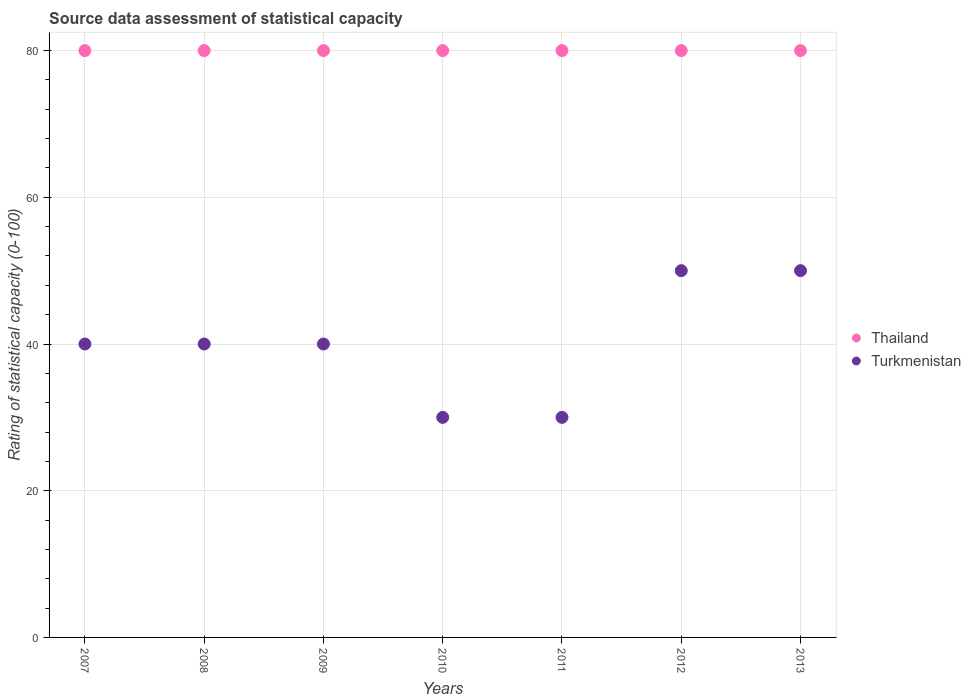How many different coloured dotlines are there?
Provide a short and direct response. 2. What is the rating of statistical capacity in Thailand in 2007?
Give a very brief answer. 80. Across all years, what is the maximum rating of statistical capacity in Turkmenistan?
Your answer should be compact. 50. Across all years, what is the minimum rating of statistical capacity in Thailand?
Your response must be concise. 80. What is the total rating of statistical capacity in Thailand in the graph?
Give a very brief answer. 560. What is the difference between the rating of statistical capacity in Thailand in 2007 and that in 2013?
Provide a short and direct response. 0. What is the difference between the rating of statistical capacity in Thailand in 2008 and the rating of statistical capacity in Turkmenistan in 2012?
Make the answer very short. 30. In the year 2011, what is the difference between the rating of statistical capacity in Turkmenistan and rating of statistical capacity in Thailand?
Your response must be concise. -50. What is the ratio of the rating of statistical capacity in Turkmenistan in 2010 to that in 2012?
Offer a terse response. 0.6. Is the rating of statistical capacity in Thailand in 2009 less than that in 2012?
Provide a succinct answer. No. Is the difference between the rating of statistical capacity in Turkmenistan in 2008 and 2012 greater than the difference between the rating of statistical capacity in Thailand in 2008 and 2012?
Your response must be concise. No. What is the difference between the highest and the lowest rating of statistical capacity in Turkmenistan?
Offer a terse response. 20. In how many years, is the rating of statistical capacity in Thailand greater than the average rating of statistical capacity in Thailand taken over all years?
Provide a short and direct response. 0. Does the rating of statistical capacity in Turkmenistan monotonically increase over the years?
Offer a terse response. No. Does the graph contain any zero values?
Provide a short and direct response. No. Does the graph contain grids?
Ensure brevity in your answer.  Yes. How many legend labels are there?
Your answer should be very brief. 2. How are the legend labels stacked?
Provide a short and direct response. Vertical. What is the title of the graph?
Offer a terse response. Source data assessment of statistical capacity. Does "Virgin Islands" appear as one of the legend labels in the graph?
Give a very brief answer. No. What is the label or title of the Y-axis?
Provide a succinct answer. Rating of statistical capacity (0-100). What is the Rating of statistical capacity (0-100) in Thailand in 2007?
Offer a terse response. 80. What is the Rating of statistical capacity (0-100) in Thailand in 2008?
Your response must be concise. 80. What is the Rating of statistical capacity (0-100) of Thailand in 2009?
Offer a very short reply. 80. What is the Rating of statistical capacity (0-100) in Thailand in 2011?
Your response must be concise. 80. What is the Rating of statistical capacity (0-100) of Turkmenistan in 2012?
Your response must be concise. 50. What is the Rating of statistical capacity (0-100) in Thailand in 2013?
Your response must be concise. 80. Across all years, what is the maximum Rating of statistical capacity (0-100) in Turkmenistan?
Your response must be concise. 50. Across all years, what is the minimum Rating of statistical capacity (0-100) in Thailand?
Provide a succinct answer. 80. Across all years, what is the minimum Rating of statistical capacity (0-100) in Turkmenistan?
Give a very brief answer. 30. What is the total Rating of statistical capacity (0-100) of Thailand in the graph?
Your answer should be very brief. 560. What is the total Rating of statistical capacity (0-100) in Turkmenistan in the graph?
Provide a short and direct response. 280. What is the difference between the Rating of statistical capacity (0-100) of Turkmenistan in 2007 and that in 2008?
Ensure brevity in your answer.  0. What is the difference between the Rating of statistical capacity (0-100) in Thailand in 2007 and that in 2009?
Keep it short and to the point. 0. What is the difference between the Rating of statistical capacity (0-100) of Thailand in 2007 and that in 2010?
Your answer should be very brief. 0. What is the difference between the Rating of statistical capacity (0-100) of Turkmenistan in 2007 and that in 2010?
Keep it short and to the point. 10. What is the difference between the Rating of statistical capacity (0-100) of Thailand in 2007 and that in 2011?
Keep it short and to the point. 0. What is the difference between the Rating of statistical capacity (0-100) in Turkmenistan in 2007 and that in 2011?
Your answer should be compact. 10. What is the difference between the Rating of statistical capacity (0-100) of Turkmenistan in 2007 and that in 2012?
Keep it short and to the point. -10. What is the difference between the Rating of statistical capacity (0-100) in Thailand in 2008 and that in 2010?
Provide a succinct answer. 0. What is the difference between the Rating of statistical capacity (0-100) in Turkmenistan in 2008 and that in 2010?
Offer a terse response. 10. What is the difference between the Rating of statistical capacity (0-100) in Turkmenistan in 2008 and that in 2011?
Your answer should be very brief. 10. What is the difference between the Rating of statistical capacity (0-100) of Thailand in 2008 and that in 2012?
Provide a short and direct response. 0. What is the difference between the Rating of statistical capacity (0-100) in Turkmenistan in 2008 and that in 2012?
Provide a short and direct response. -10. What is the difference between the Rating of statistical capacity (0-100) in Thailand in 2008 and that in 2013?
Ensure brevity in your answer.  0. What is the difference between the Rating of statistical capacity (0-100) in Turkmenistan in 2008 and that in 2013?
Provide a short and direct response. -10. What is the difference between the Rating of statistical capacity (0-100) of Thailand in 2009 and that in 2011?
Offer a terse response. 0. What is the difference between the Rating of statistical capacity (0-100) of Turkmenistan in 2009 and that in 2011?
Make the answer very short. 10. What is the difference between the Rating of statistical capacity (0-100) of Turkmenistan in 2009 and that in 2012?
Provide a succinct answer. -10. What is the difference between the Rating of statistical capacity (0-100) in Thailand in 2009 and that in 2013?
Make the answer very short. 0. What is the difference between the Rating of statistical capacity (0-100) in Turkmenistan in 2009 and that in 2013?
Your answer should be very brief. -10. What is the difference between the Rating of statistical capacity (0-100) of Thailand in 2010 and that in 2012?
Offer a terse response. 0. What is the difference between the Rating of statistical capacity (0-100) of Turkmenistan in 2010 and that in 2012?
Offer a terse response. -20. What is the difference between the Rating of statistical capacity (0-100) of Thailand in 2011 and that in 2012?
Provide a short and direct response. 0. What is the difference between the Rating of statistical capacity (0-100) in Thailand in 2011 and that in 2013?
Your answer should be very brief. 0. What is the difference between the Rating of statistical capacity (0-100) in Thailand in 2012 and that in 2013?
Your answer should be compact. 0. What is the difference between the Rating of statistical capacity (0-100) of Turkmenistan in 2012 and that in 2013?
Your response must be concise. 0. What is the difference between the Rating of statistical capacity (0-100) in Thailand in 2007 and the Rating of statistical capacity (0-100) in Turkmenistan in 2012?
Provide a succinct answer. 30. What is the difference between the Rating of statistical capacity (0-100) of Thailand in 2007 and the Rating of statistical capacity (0-100) of Turkmenistan in 2013?
Provide a short and direct response. 30. What is the difference between the Rating of statistical capacity (0-100) of Thailand in 2008 and the Rating of statistical capacity (0-100) of Turkmenistan in 2009?
Offer a very short reply. 40. What is the difference between the Rating of statistical capacity (0-100) in Thailand in 2008 and the Rating of statistical capacity (0-100) in Turkmenistan in 2011?
Provide a succinct answer. 50. What is the difference between the Rating of statistical capacity (0-100) of Thailand in 2008 and the Rating of statistical capacity (0-100) of Turkmenistan in 2012?
Your response must be concise. 30. What is the difference between the Rating of statistical capacity (0-100) of Thailand in 2009 and the Rating of statistical capacity (0-100) of Turkmenistan in 2010?
Your answer should be very brief. 50. What is the difference between the Rating of statistical capacity (0-100) of Thailand in 2009 and the Rating of statistical capacity (0-100) of Turkmenistan in 2011?
Make the answer very short. 50. What is the difference between the Rating of statistical capacity (0-100) of Thailand in 2009 and the Rating of statistical capacity (0-100) of Turkmenistan in 2013?
Ensure brevity in your answer.  30. What is the difference between the Rating of statistical capacity (0-100) in Thailand in 2010 and the Rating of statistical capacity (0-100) in Turkmenistan in 2012?
Offer a very short reply. 30. In the year 2007, what is the difference between the Rating of statistical capacity (0-100) of Thailand and Rating of statistical capacity (0-100) of Turkmenistan?
Keep it short and to the point. 40. In the year 2010, what is the difference between the Rating of statistical capacity (0-100) of Thailand and Rating of statistical capacity (0-100) of Turkmenistan?
Your response must be concise. 50. In the year 2013, what is the difference between the Rating of statistical capacity (0-100) of Thailand and Rating of statistical capacity (0-100) of Turkmenistan?
Make the answer very short. 30. What is the ratio of the Rating of statistical capacity (0-100) of Thailand in 2007 to that in 2008?
Offer a very short reply. 1. What is the ratio of the Rating of statistical capacity (0-100) in Turkmenistan in 2007 to that in 2008?
Your response must be concise. 1. What is the ratio of the Rating of statistical capacity (0-100) in Thailand in 2007 to that in 2012?
Your answer should be compact. 1. What is the ratio of the Rating of statistical capacity (0-100) in Thailand in 2007 to that in 2013?
Ensure brevity in your answer.  1. What is the ratio of the Rating of statistical capacity (0-100) of Turkmenistan in 2007 to that in 2013?
Make the answer very short. 0.8. What is the ratio of the Rating of statistical capacity (0-100) in Turkmenistan in 2008 to that in 2009?
Offer a very short reply. 1. What is the ratio of the Rating of statistical capacity (0-100) of Turkmenistan in 2008 to that in 2010?
Offer a terse response. 1.33. What is the ratio of the Rating of statistical capacity (0-100) in Thailand in 2008 to that in 2013?
Provide a short and direct response. 1. What is the ratio of the Rating of statistical capacity (0-100) in Turkmenistan in 2008 to that in 2013?
Make the answer very short. 0.8. What is the ratio of the Rating of statistical capacity (0-100) in Turkmenistan in 2009 to that in 2010?
Your response must be concise. 1.33. What is the ratio of the Rating of statistical capacity (0-100) in Thailand in 2009 to that in 2011?
Your answer should be very brief. 1. What is the ratio of the Rating of statistical capacity (0-100) in Turkmenistan in 2009 to that in 2011?
Make the answer very short. 1.33. What is the ratio of the Rating of statistical capacity (0-100) of Thailand in 2009 to that in 2012?
Make the answer very short. 1. What is the ratio of the Rating of statistical capacity (0-100) in Turkmenistan in 2009 to that in 2012?
Offer a terse response. 0.8. What is the ratio of the Rating of statistical capacity (0-100) of Turkmenistan in 2010 to that in 2011?
Offer a terse response. 1. What is the ratio of the Rating of statistical capacity (0-100) in Thailand in 2010 to that in 2012?
Provide a short and direct response. 1. What is the ratio of the Rating of statistical capacity (0-100) of Turkmenistan in 2010 to that in 2012?
Your response must be concise. 0.6. What is the ratio of the Rating of statistical capacity (0-100) of Thailand in 2010 to that in 2013?
Make the answer very short. 1. What is the ratio of the Rating of statistical capacity (0-100) of Thailand in 2011 to that in 2012?
Offer a very short reply. 1. What is the ratio of the Rating of statistical capacity (0-100) in Thailand in 2011 to that in 2013?
Your response must be concise. 1. What is the ratio of the Rating of statistical capacity (0-100) of Thailand in 2012 to that in 2013?
Your answer should be very brief. 1. What is the difference between the highest and the lowest Rating of statistical capacity (0-100) of Thailand?
Your response must be concise. 0. What is the difference between the highest and the lowest Rating of statistical capacity (0-100) of Turkmenistan?
Offer a terse response. 20. 